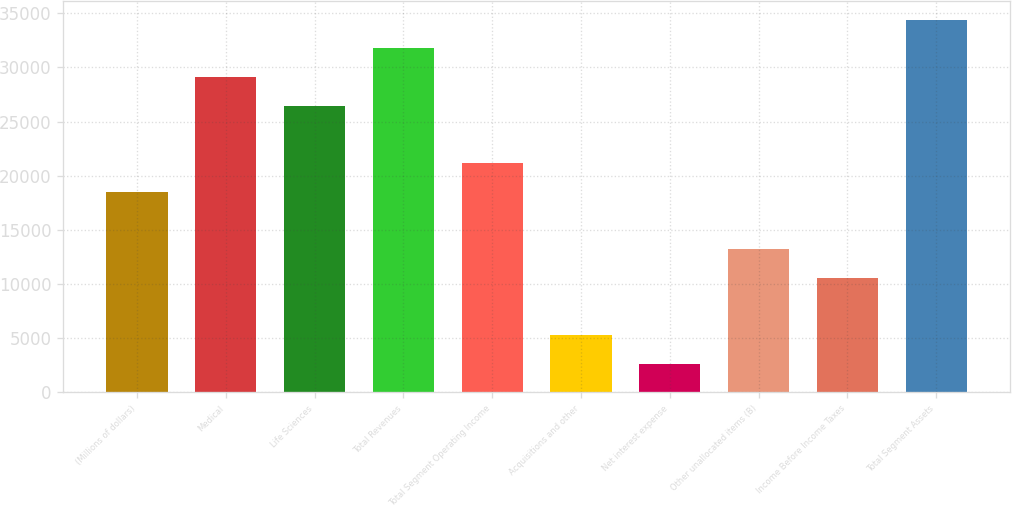Convert chart. <chart><loc_0><loc_0><loc_500><loc_500><bar_chart><fcel>(Millions of dollars)<fcel>Medical<fcel>Life Sciences<fcel>Total Revenues<fcel>Total Segment Operating Income<fcel>Acquisitions and other<fcel>Net interest expense<fcel>Other unallocated items (B)<fcel>Income Before Income Taxes<fcel>Total Segment Assets<nl><fcel>18538.8<fcel>29124.4<fcel>26478<fcel>31770.8<fcel>21185.2<fcel>5306.8<fcel>2660.4<fcel>13246<fcel>10599.6<fcel>34417.2<nl></chart> 